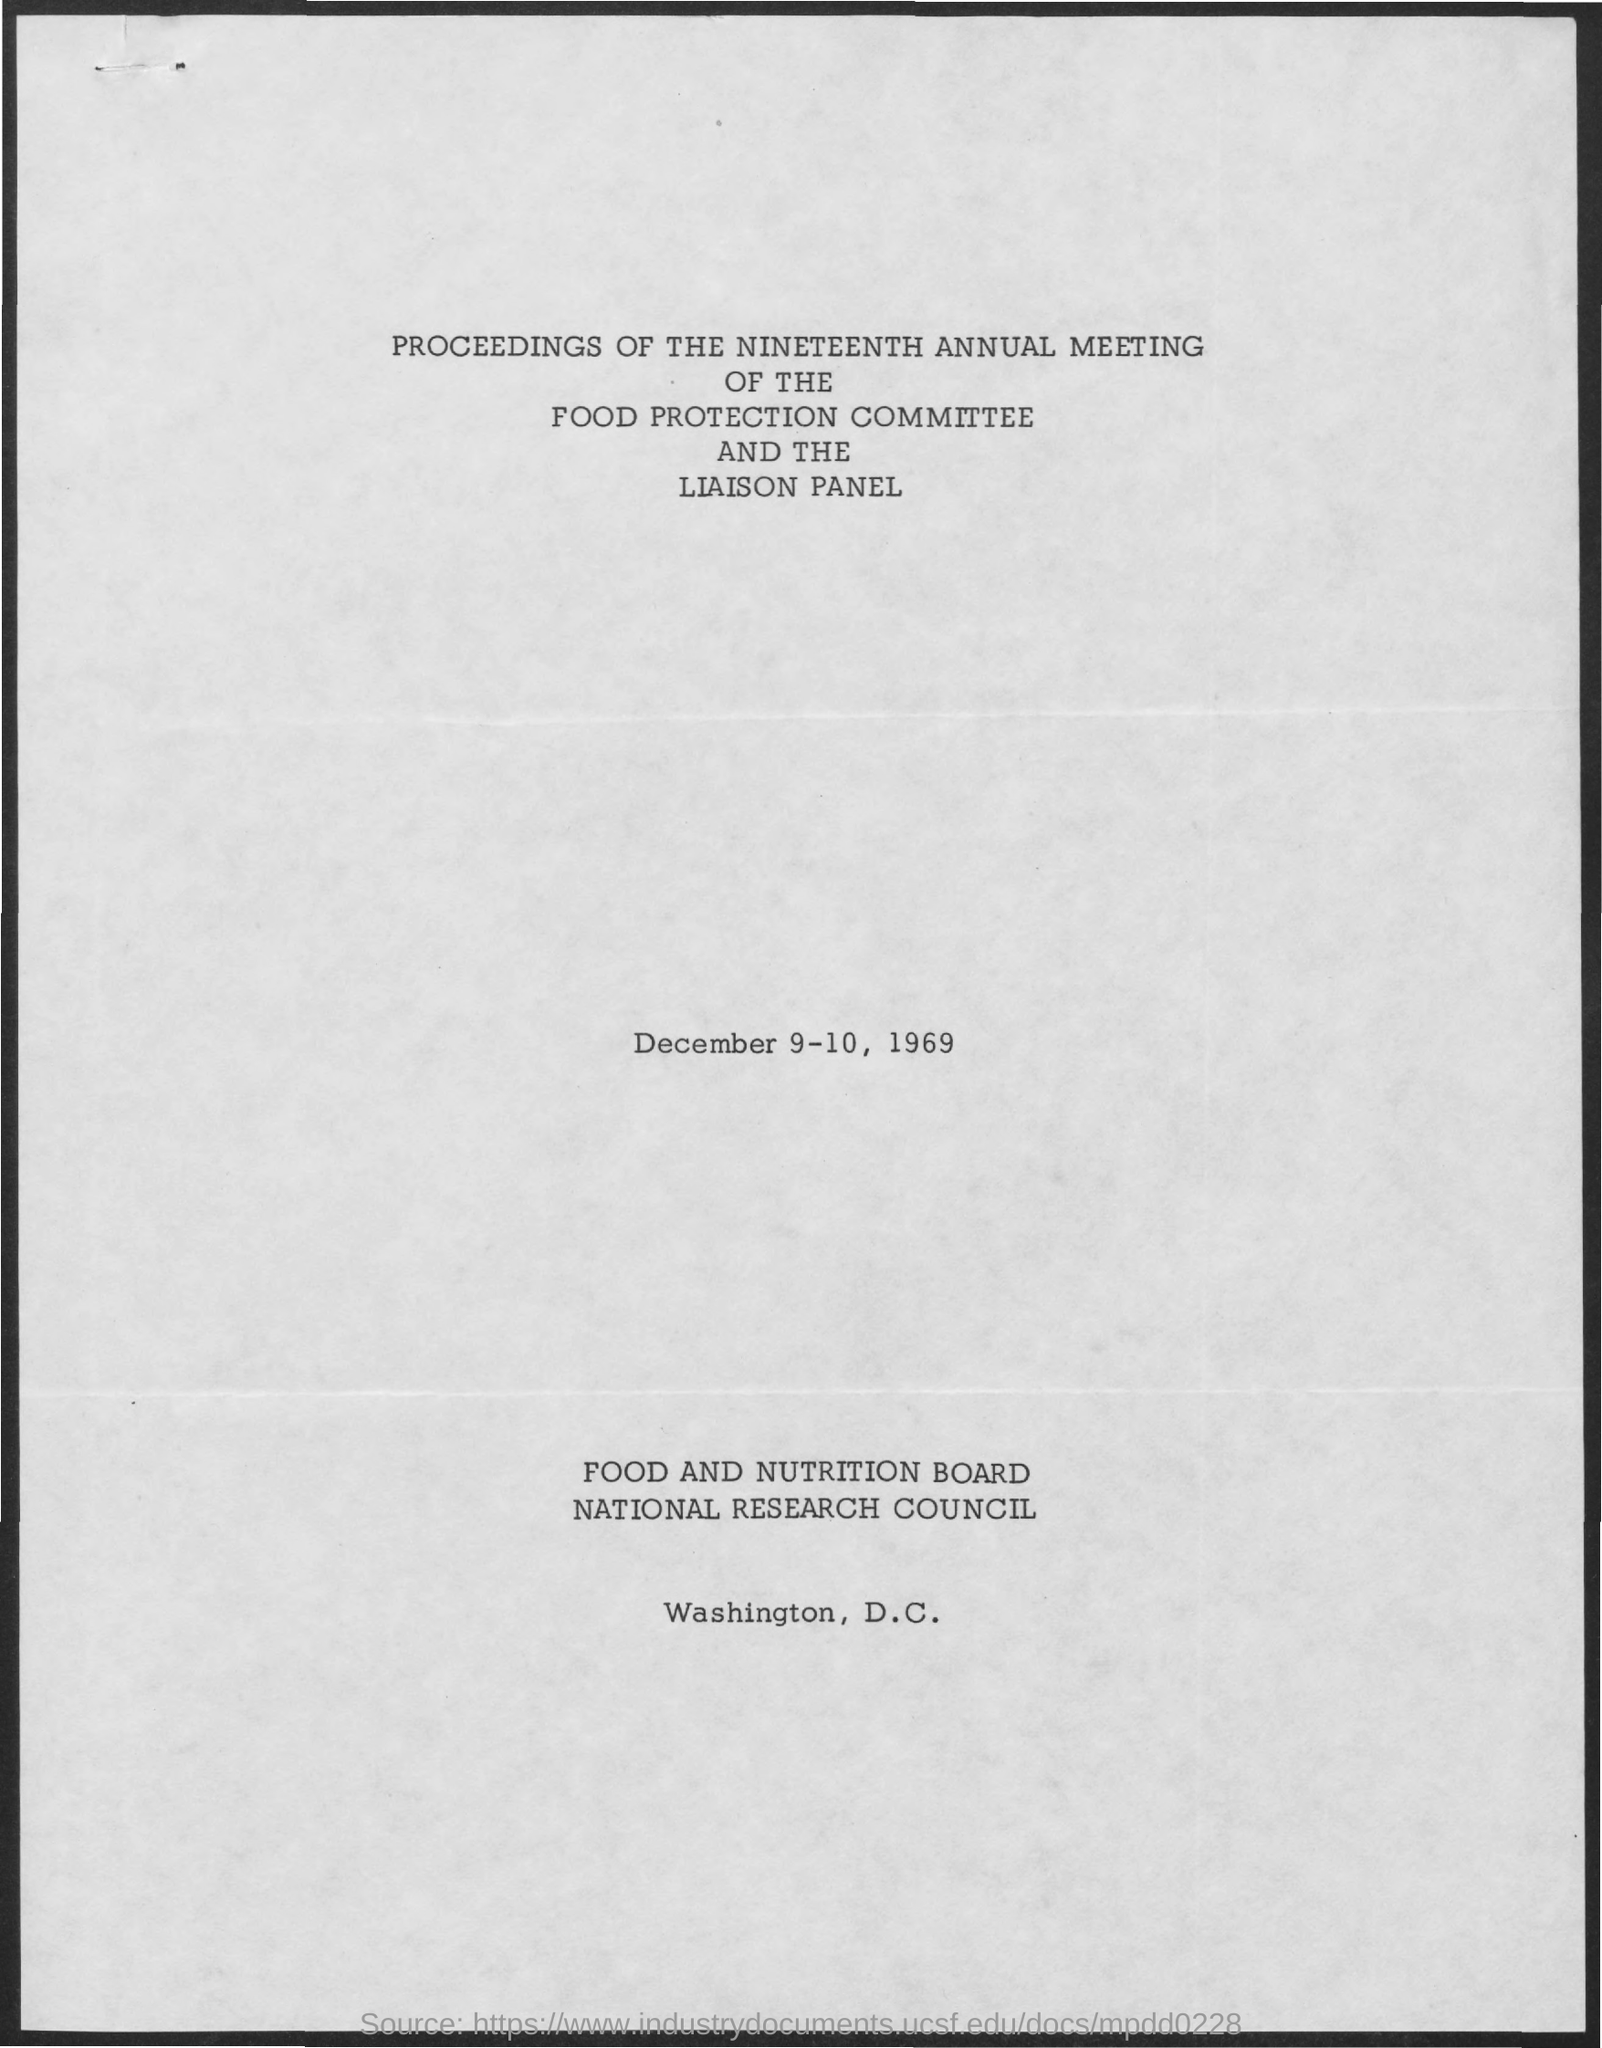Indicate a few pertinent items in this graphic. The nineteenth annual meeting of the food protection committee and the liaison panel was held on December 9-10, 1969. 